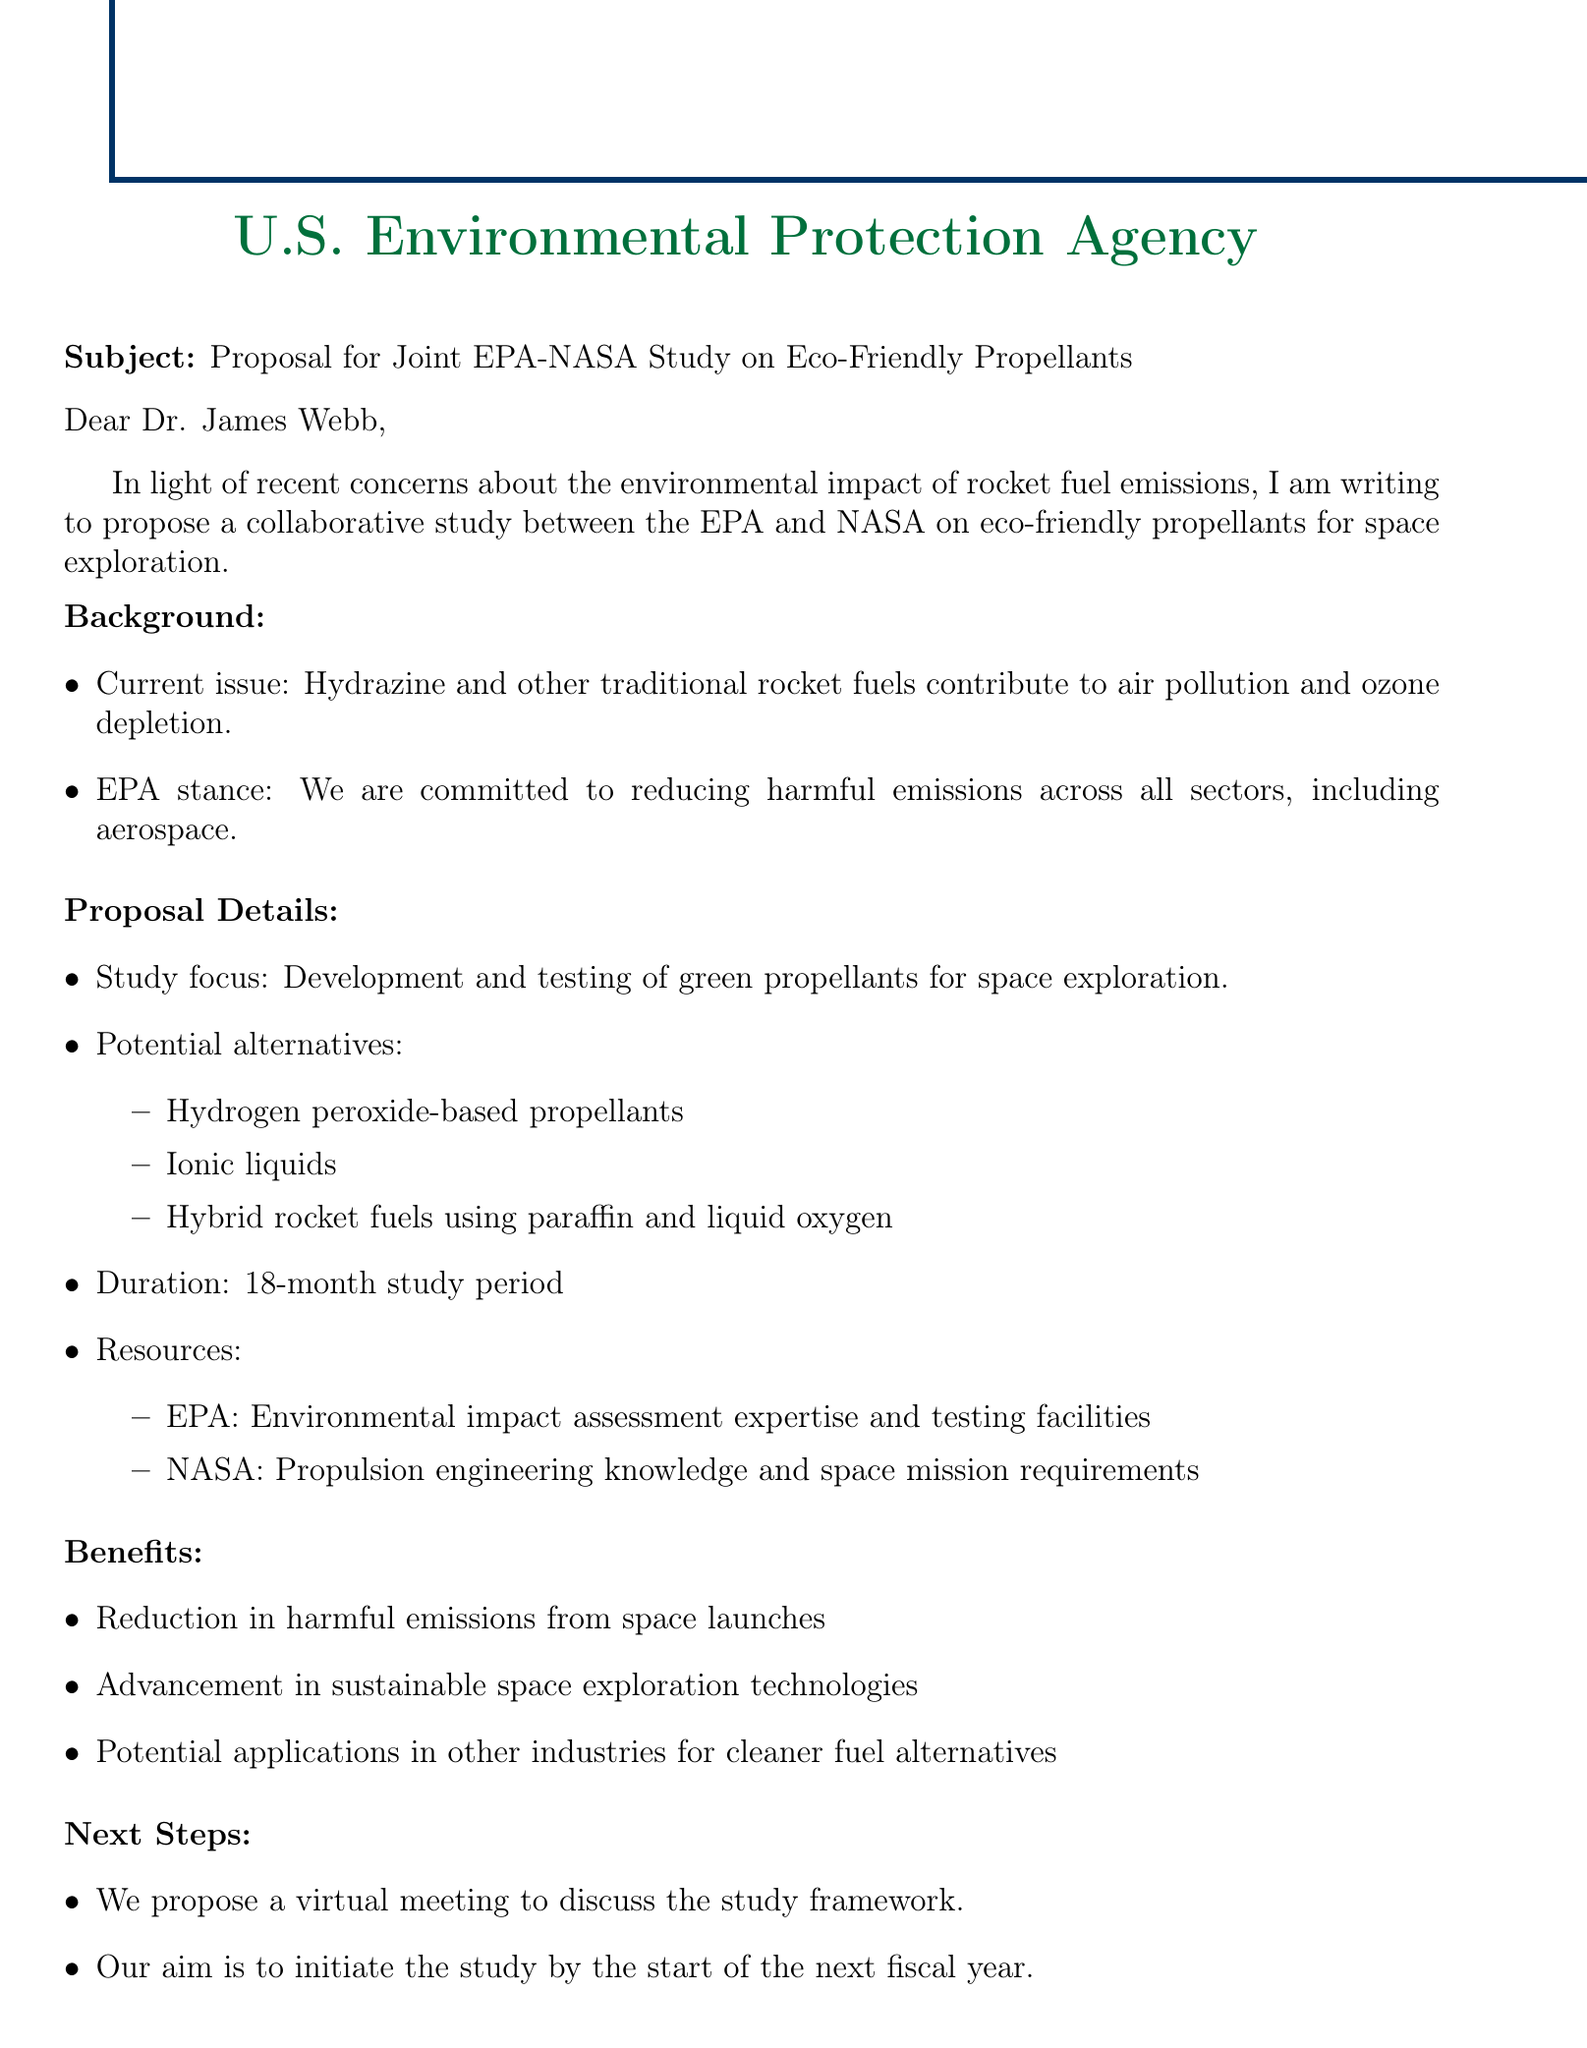what is the main purpose of the email? The main purpose is to propose a collaborative study between the EPA and NASA on eco-friendly propellants for space exploration.
Answer: propose a collaborative study who is the email addressed to? The email is addressed to Dr. James Webb.
Answer: Dr. James Webb what is the duration of the proposed study? The duration of the study is specified as 18 months.
Answer: 18 months name one of the potential alternative propellants mentioned. One of the potential alternatives mentioned is hydrogen peroxide-based propellants.
Answer: hydrogen peroxide-based propellants what potential benefit is mentioned regarding other industries? The potential benefit for other industries is for cleaner fuel alternatives.
Answer: cleaner fuel alternatives what is the EPA's stance mentioned in the email? The EPA's stance is their commitment to reducing harmful emissions across all sectors, including aerospace.
Answer: reducing harmful emissions what is proposed as the next step in the collaboration? The next step proposed is to have a virtual meeting to discuss the study framework.
Answer: virtual meeting how should the recipient contact the sender? The recipient should contact the sender via email or phone.
Answer: email or phone who is the sender of the email? The sender is John Smith, who holds the position of Senior Environmental Scientist.
Answer: John Smith 